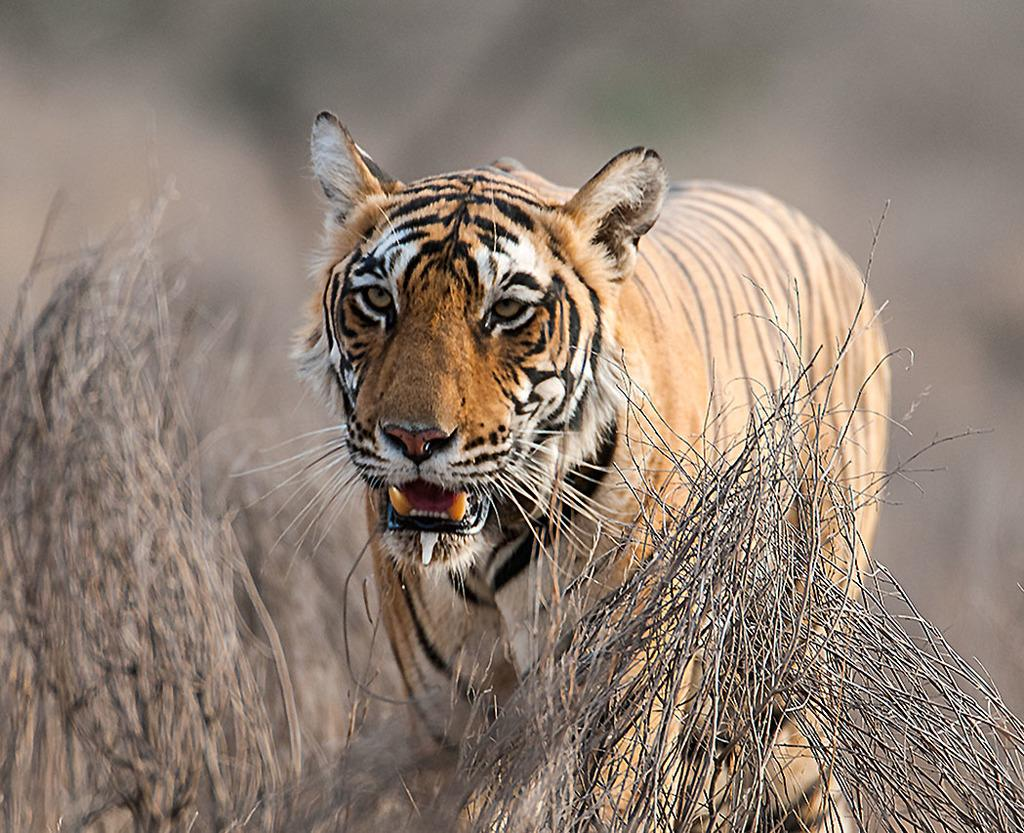What animal is the main subject of the image? There is a tiger in the image. Where is the tiger located in the image? The tiger is standing in the middle of the image. What type of environment is depicted in the image? The grassland in the image appears to be dry. How many people are pushing the tiger in the image? There are no people present in the image, and the tiger is not being pushed. 